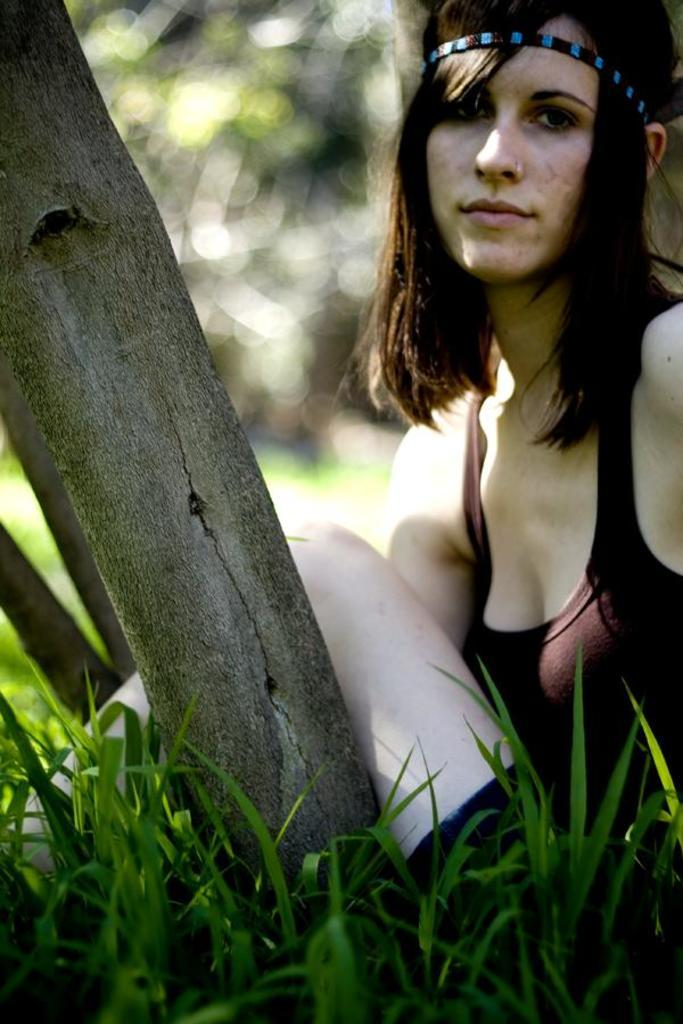What is the woman in the image doing? The woman is sitting in the image. What is the woman wearing on her head? The woman is wearing a headband. What type of clothing is the woman wearing? The woman is wearing a dress. What type of natural environment is visible in the image? There is grass visible in the image. What object can be seen near the grass? There is a tree trunk in the image. How would you describe the background of the image? The background of the image appears blurry. What type of chicken can be seen in the image? There is no chicken present in the image. 